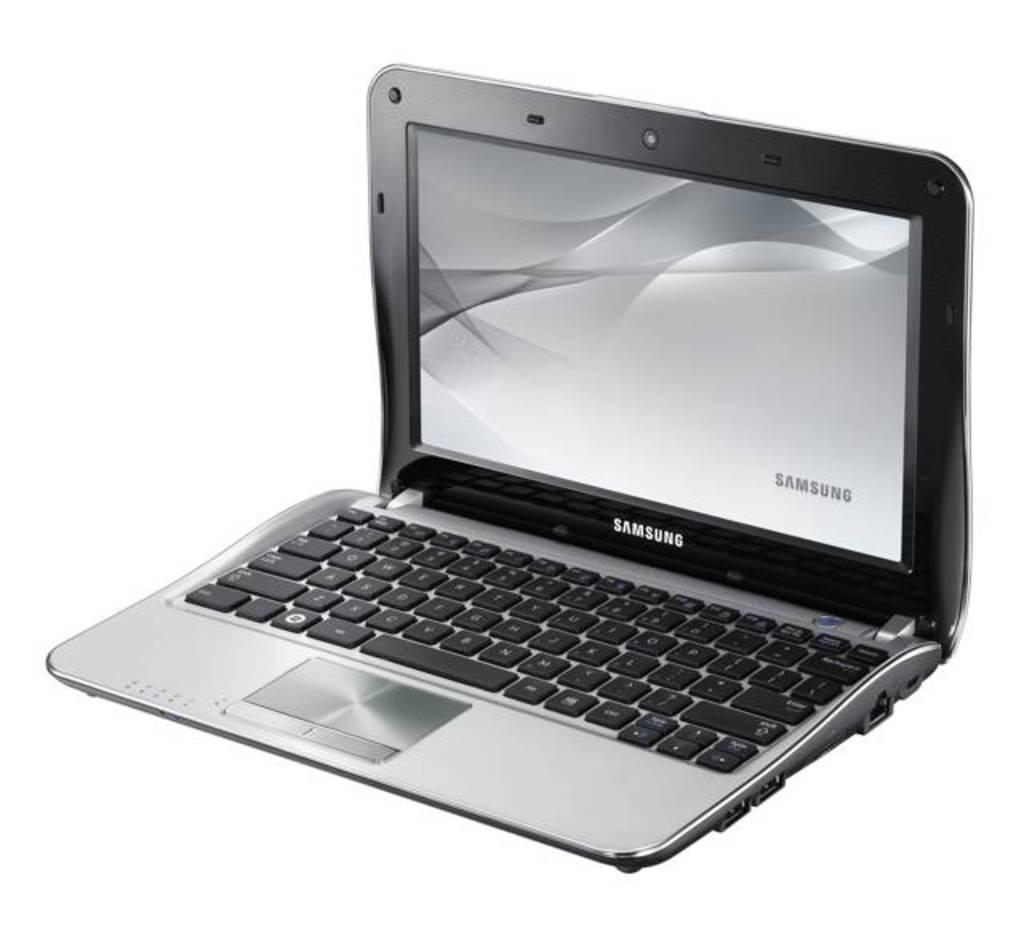<image>
Share a concise interpretation of the image provided. a small laptop with the samsung logo on it in silver lettering 